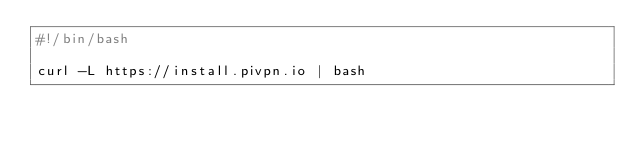<code> <loc_0><loc_0><loc_500><loc_500><_Bash_>#!/bin/bash

curl -L https://install.pivpn.io | bash
</code> 